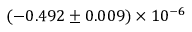<formula> <loc_0><loc_0><loc_500><loc_500>( - 0 . 4 9 2 \pm 0 . 0 0 9 ) \times 1 0 ^ { - 6 }</formula> 